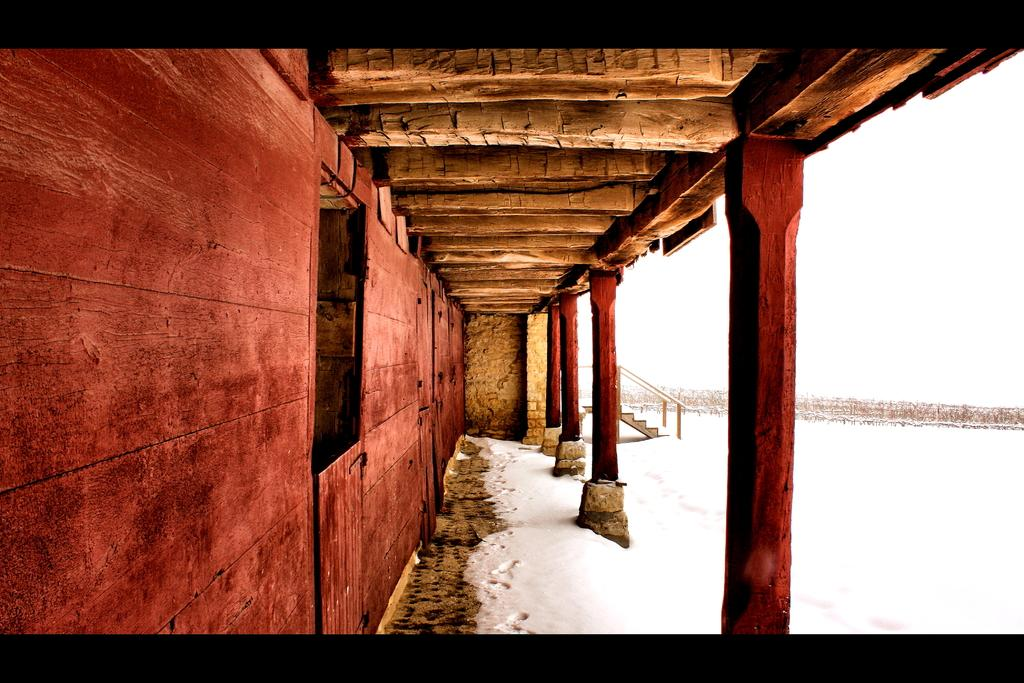What architectural features can be seen in the image? There are pillars and a wall in the image. Are there any other structural elements present? Yes, there are steps in the image. What can be observed in the background of the image? There is snow visible in the background of the image. What type of voice can be heard coming from the pillars in the image? There is no voice present in the image; it only features pillars, a wall, steps, and snow in the background. 